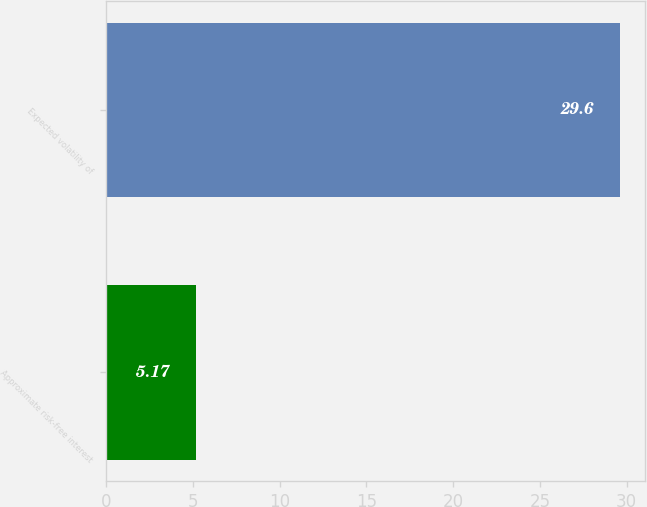<chart> <loc_0><loc_0><loc_500><loc_500><bar_chart><fcel>Approximate risk-free interest<fcel>Expected volatility of<nl><fcel>5.17<fcel>29.6<nl></chart> 